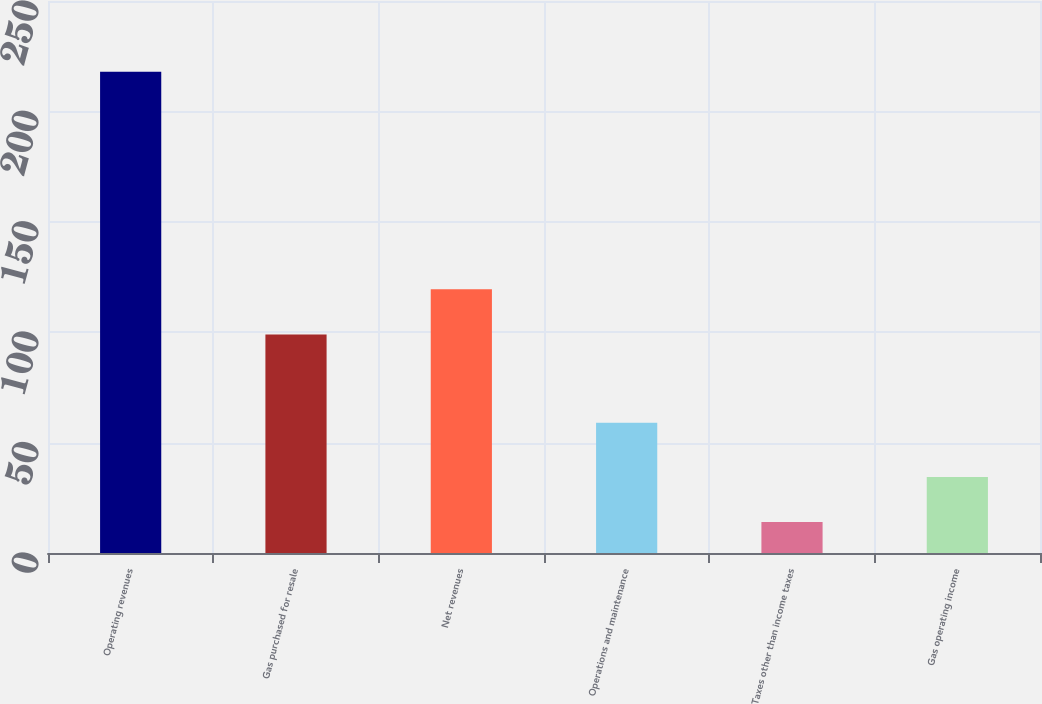Convert chart. <chart><loc_0><loc_0><loc_500><loc_500><bar_chart><fcel>Operating revenues<fcel>Gas purchased for resale<fcel>Net revenues<fcel>Operations and maintenance<fcel>Taxes other than income taxes<fcel>Gas operating income<nl><fcel>218<fcel>99<fcel>119.4<fcel>59<fcel>14<fcel>34.4<nl></chart> 